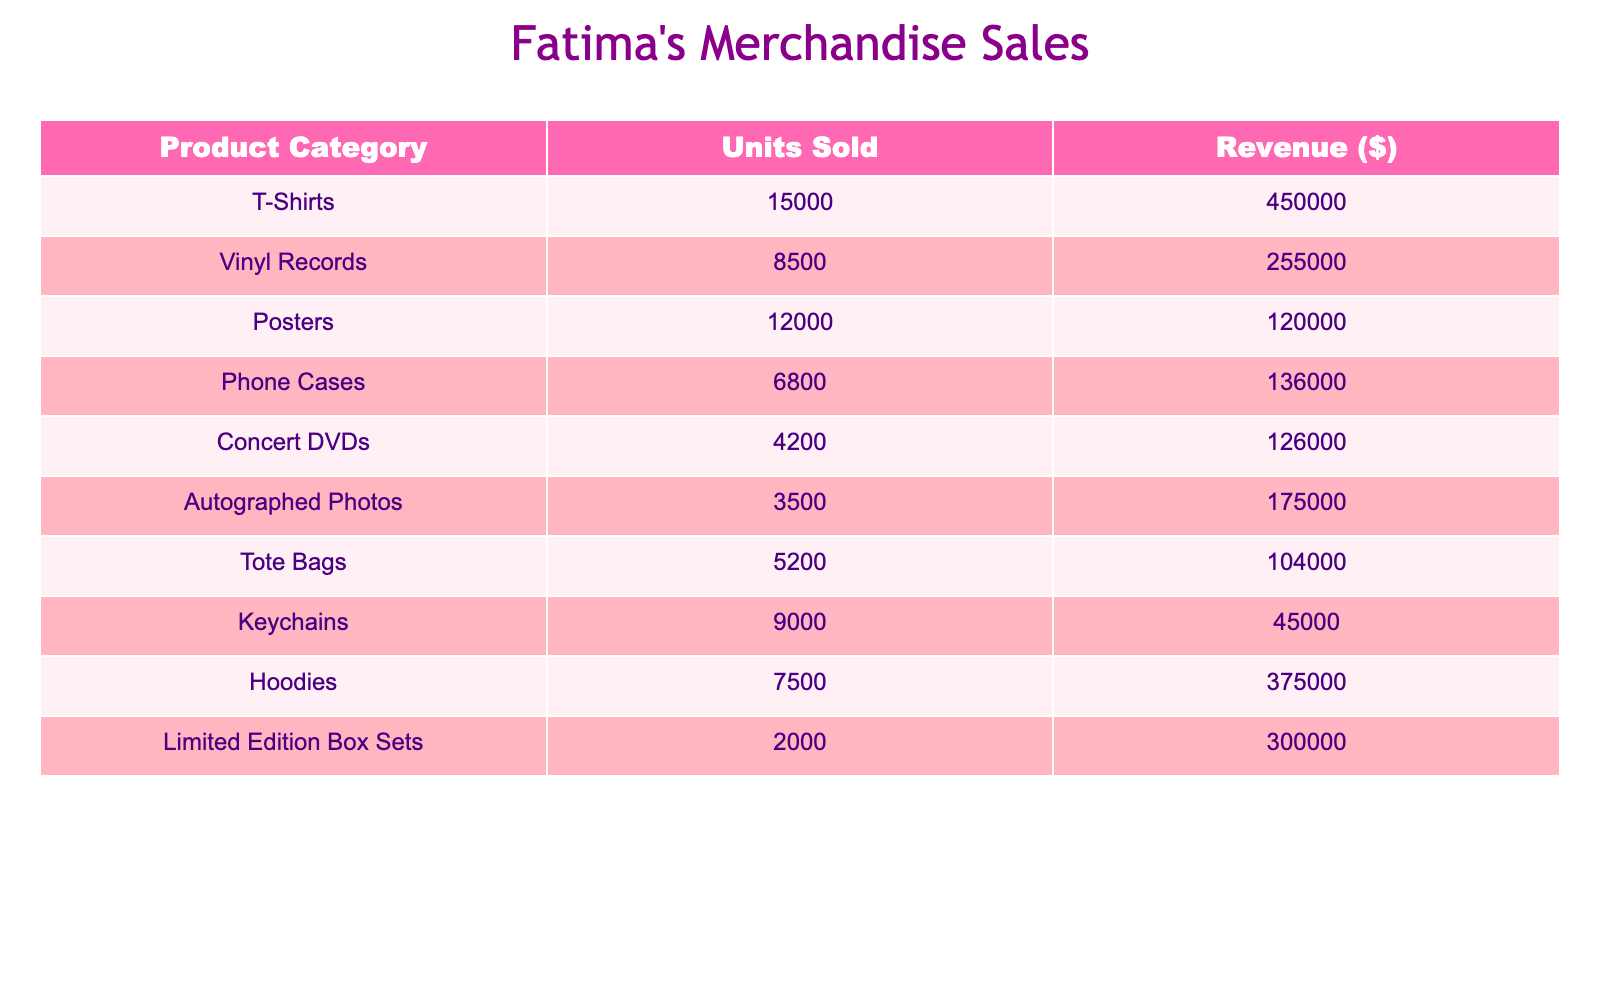What is the total revenue from T-Shirts? The revenue from T-Shirts is listed as $450,000. Therefore, the total revenue from this product category is $450,000.
Answer: $450,000 How many units of Phone Cases were sold? The table states that 6,800 units of Phone Cases were sold.
Answer: 6,800 Which product category generated the highest revenue? By comparing the revenue figures, T-Shirts generated the highest revenue at $450,000.
Answer: T-Shirts What is the total number of units sold across all categories? Adding up the units sold: 15,000 (T-Shirts) + 8,500 (Vinyl Records) + 12,000 (Posters) + 6,800 (Phone Cases) + 4,200 (Concert DVDs) + 3,500 (Autographed Photos) + 5,200 (Tote Bags) + 9,000 (Keychains) + 7,500 (Hoodies) + 2,000 (Limited Edition Box Sets) = 73,700 units.
Answer: 73,700 Is the revenue from Limited Edition Box Sets greater than the combined revenue of Phone Cases and Keychains? The revenue from Limited Edition Box Sets is $300,000. Revenue from Phone Cases is $136,000 and from Keychains is $45,000. Combined revenue from Phone Cases and Keychains = $136,000 + $45,000 = $181,000, which is less than $300,000. Therefore, the statement is true.
Answer: Yes What is the average number of units sold per product category? There are 10 product categories. Total units sold is 73,700. Average = Total Units Sold / Number of Categories = 73,700 / 10 = 7,370.
Answer: 7,370 Which category had the lowest number of units sold? The least units sold is found in the Autographed Photos category, which has 3,500 units sold.
Answer: Autographed Photos What is the difference in revenue between the highest and lowest selling product categories? The highest revenue is from T-Shirts at $450,000, and the lowest is from Keychains at $45,000. The difference = $450,000 - $45,000 = $405,000.
Answer: $405,000 If you combine the revenue of Hoodies and Concert DVDs, does it exceed the revenue from Vinyl Records? Revenue from Hoodies is $375,000 and from Concert DVDs is $126,000, together $375,000 + $126,000 = $501,000. Revenue from Vinyl Records is $255,000. Since $501,000 > $255,000, the combined revenue does exceed that of Vinyl Records.
Answer: Yes What percentage of the total units sold are T-Shirts? T-Shirts sold 15,000 units out of a total of 73,700 units. To find the percentage: (15,000 / 73,700) * 100 = 20.34%.
Answer: 20.34% What product category had more units sold: Tote Bags or Autographed Photos? Tote Bags sold 5,200 units and Autographed Photos sold 3,500 units. Comparing these figures, Tote Bags sold more than Autographed Photos.
Answer: Tote Bags 